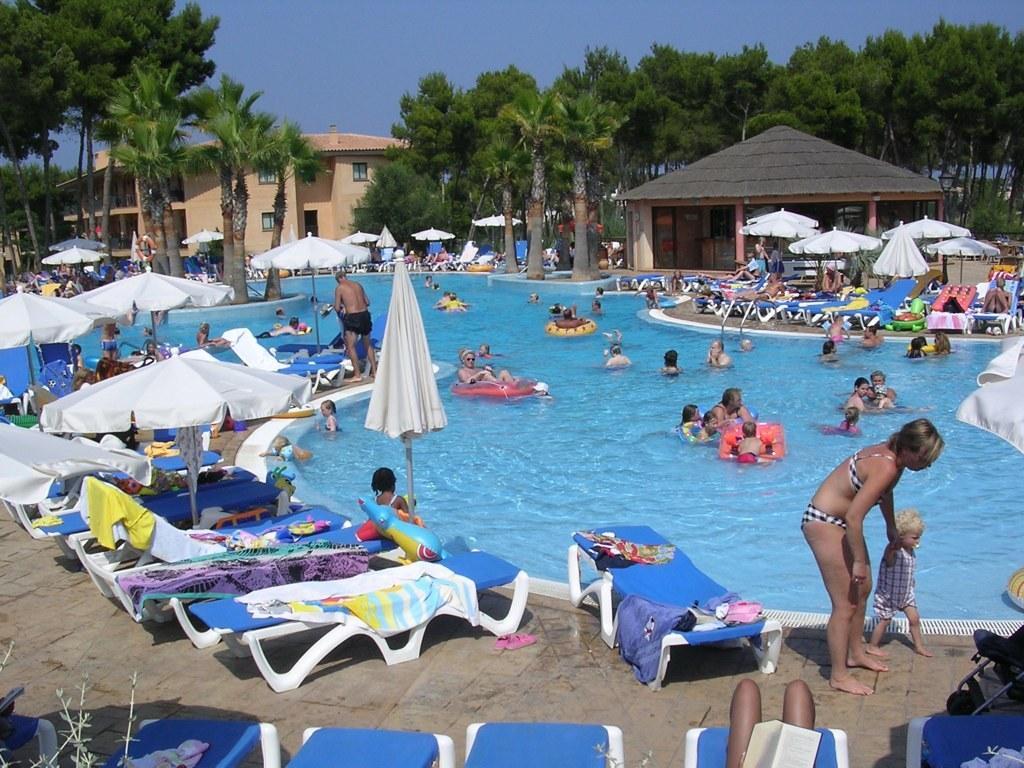Could you give a brief overview of what you see in this image? In the front portion of the image we can see people, umbrellas, swimming pool, tubes, chairs, clothes and things. In the background portion of the image we can see trees, sky, shed and building.  